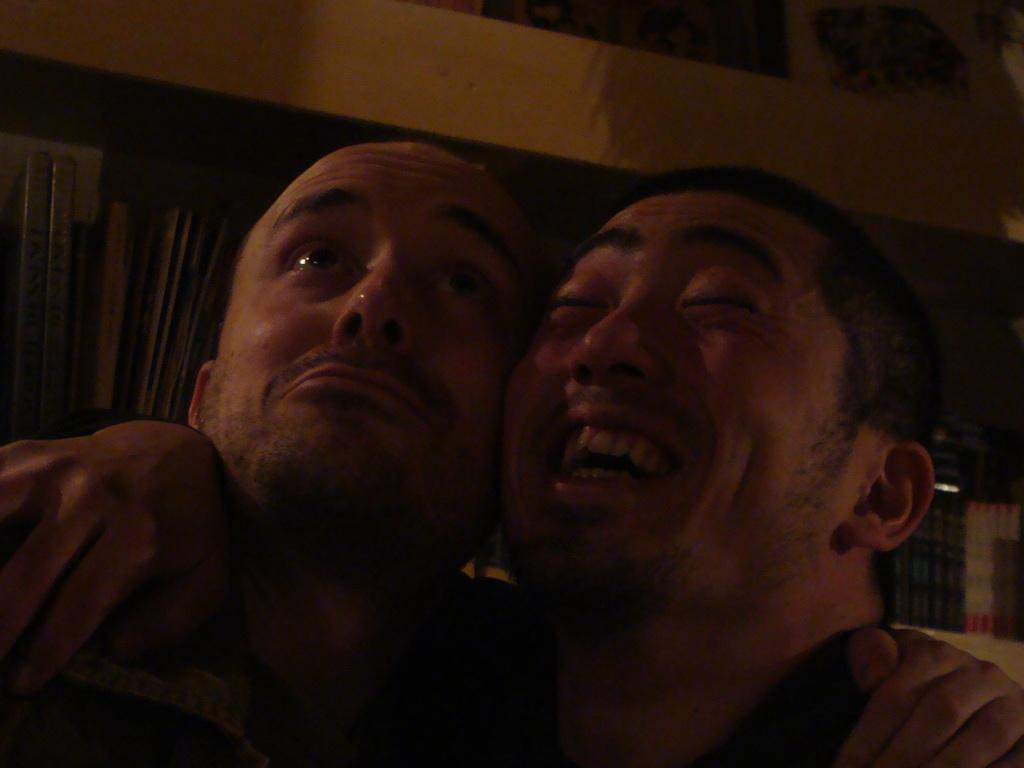How many people are in the image? There are two persons in the image. Can you describe the background visible in the image? Unfortunately, the provided facts do not give any information about the background. What type of watch is the person on the left wearing in the image? There is no information about watches or any accessories worn by the persons in the image. 